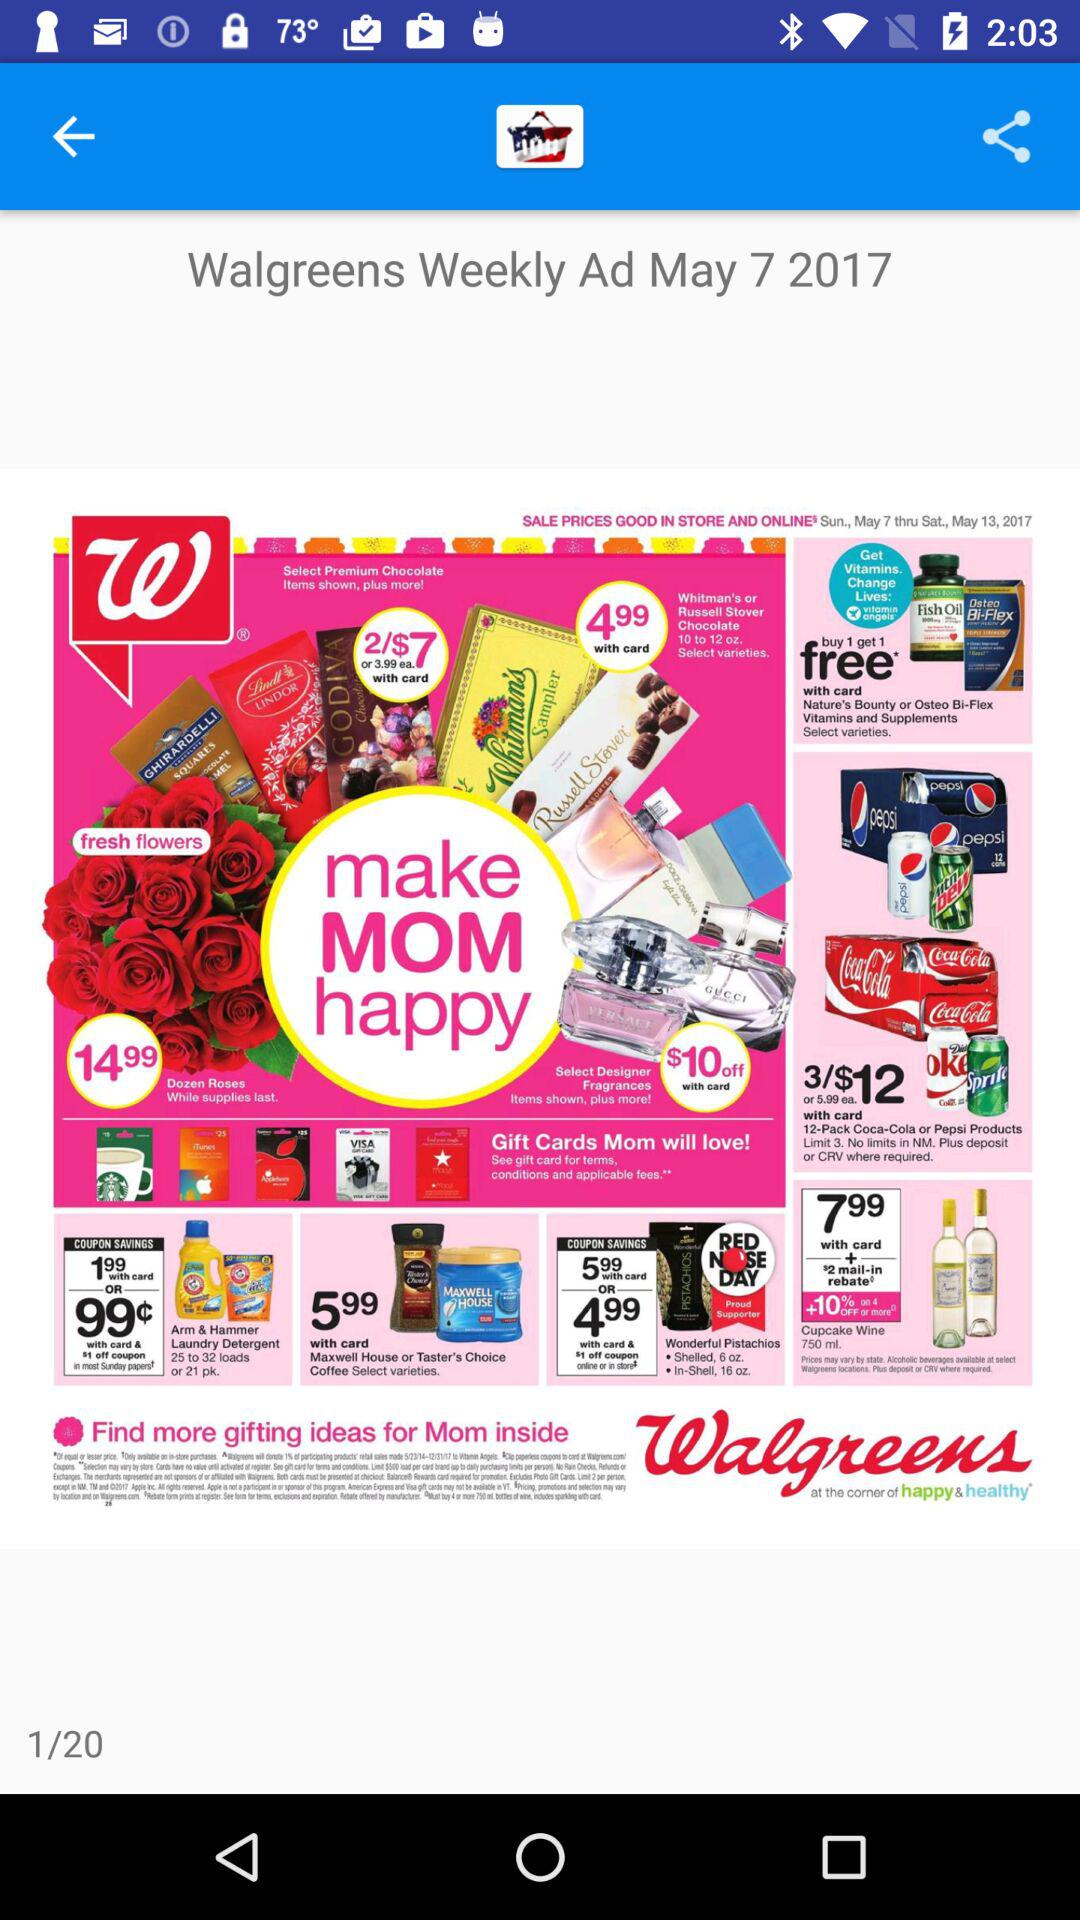What is the mentioned date? The mentioned date is May 7, 2017. 